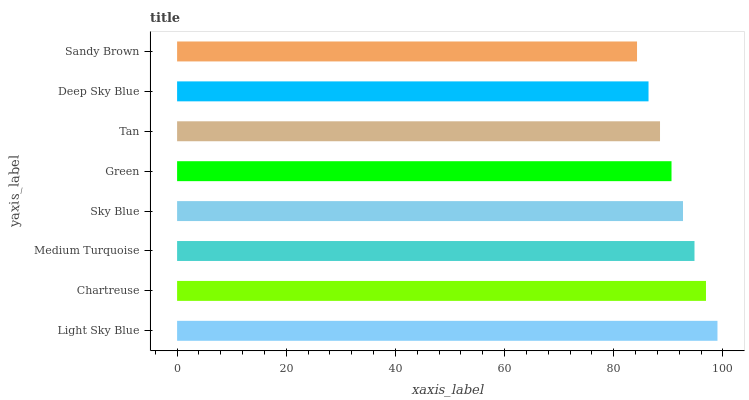Is Sandy Brown the minimum?
Answer yes or no. Yes. Is Light Sky Blue the maximum?
Answer yes or no. Yes. Is Chartreuse the minimum?
Answer yes or no. No. Is Chartreuse the maximum?
Answer yes or no. No. Is Light Sky Blue greater than Chartreuse?
Answer yes or no. Yes. Is Chartreuse less than Light Sky Blue?
Answer yes or no. Yes. Is Chartreuse greater than Light Sky Blue?
Answer yes or no. No. Is Light Sky Blue less than Chartreuse?
Answer yes or no. No. Is Sky Blue the high median?
Answer yes or no. Yes. Is Green the low median?
Answer yes or no. Yes. Is Medium Turquoise the high median?
Answer yes or no. No. Is Medium Turquoise the low median?
Answer yes or no. No. 